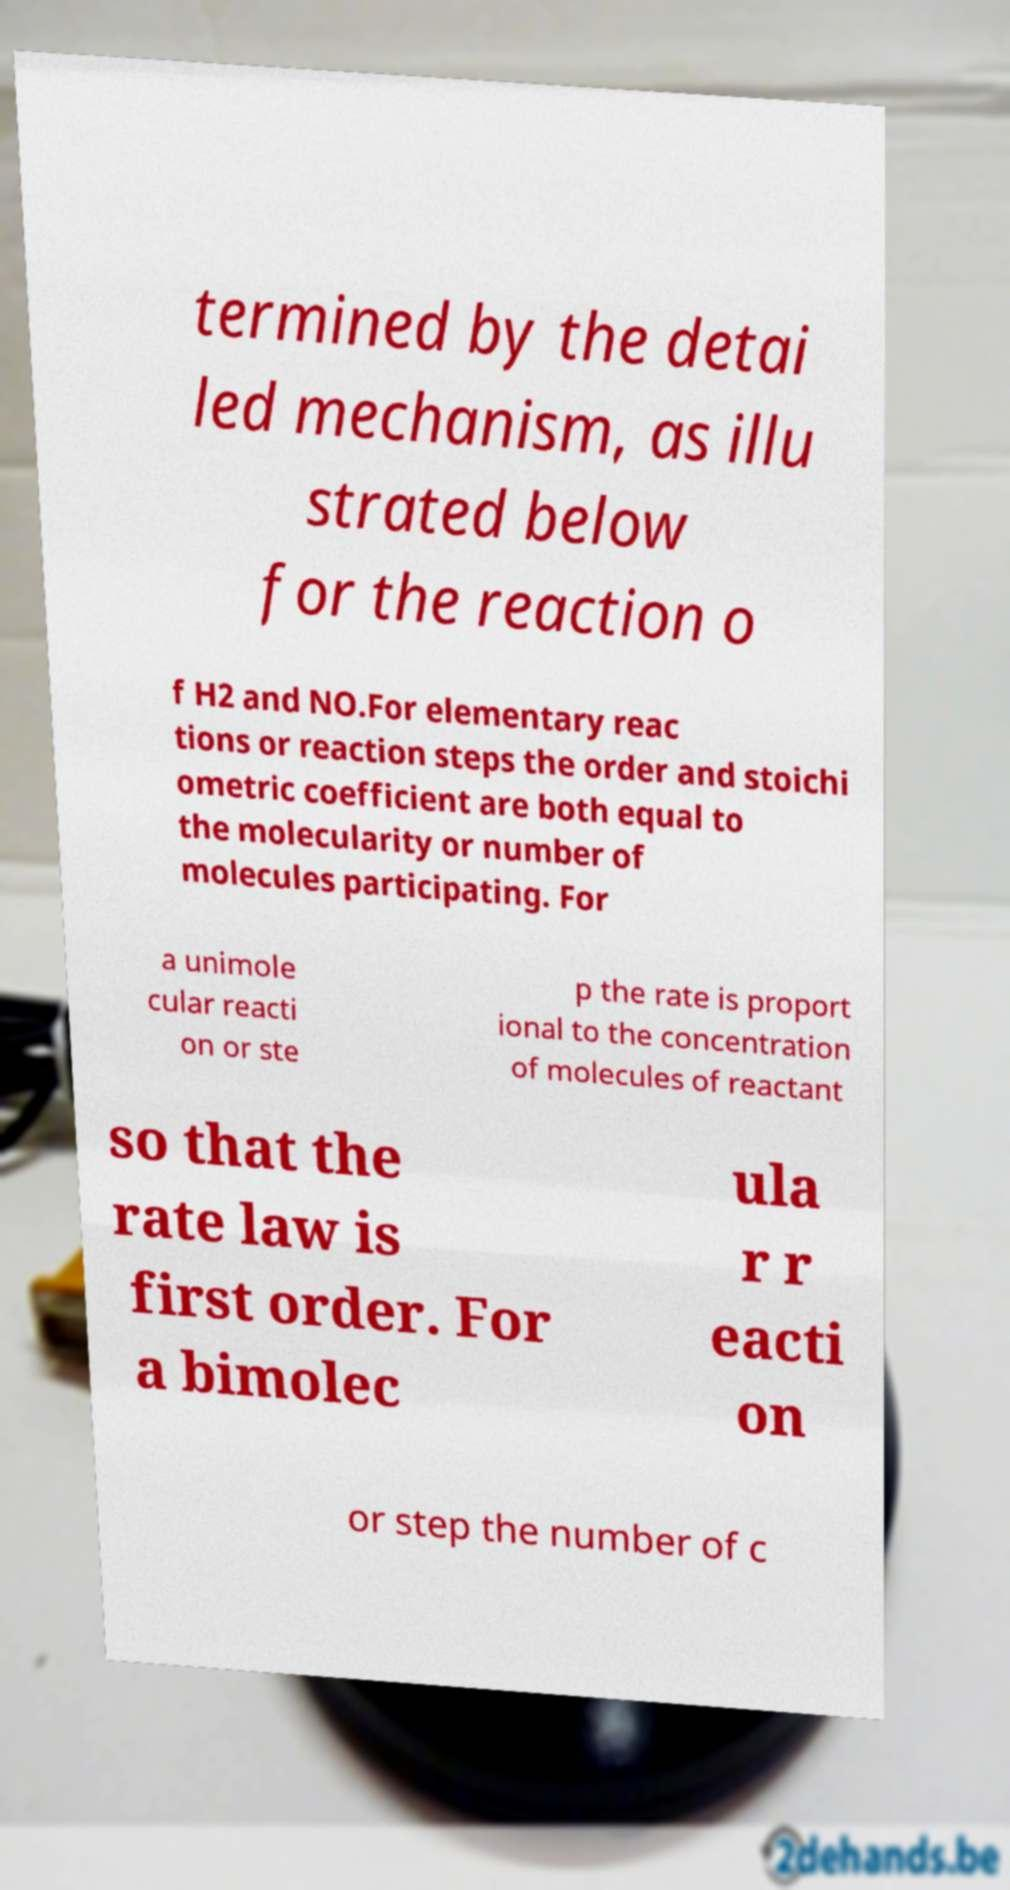There's text embedded in this image that I need extracted. Can you transcribe it verbatim? termined by the detai led mechanism, as illu strated below for the reaction o f H2 and NO.For elementary reac tions or reaction steps the order and stoichi ometric coefficient are both equal to the molecularity or number of molecules participating. For a unimole cular reacti on or ste p the rate is proport ional to the concentration of molecules of reactant so that the rate law is first order. For a bimolec ula r r eacti on or step the number of c 